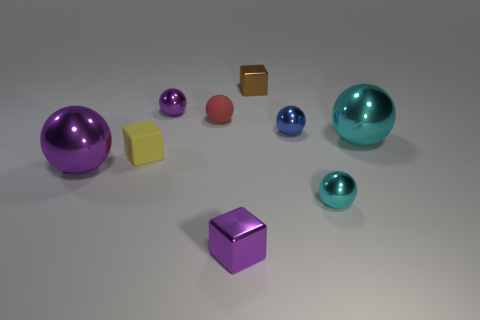What shape is the large thing right of the purple metal ball that is left of the yellow rubber object?
Ensure brevity in your answer.  Sphere. What is the shape of the small red thing on the right side of the large purple ball?
Ensure brevity in your answer.  Sphere. What number of small metallic cubes are the same color as the rubber cube?
Make the answer very short. 0. What color is the small matte cube?
Provide a succinct answer. Yellow. How many tiny cubes are on the right side of the metal block that is in front of the small purple sphere?
Make the answer very short. 1. Does the yellow object have the same size as the cyan metallic object behind the matte block?
Your answer should be very brief. No. Is there another brown cube that has the same size as the brown metal cube?
Offer a very short reply. No. There is a small purple object to the left of the purple cube; what is its material?
Give a very brief answer. Metal. What color is the block that is made of the same material as the tiny red thing?
Provide a short and direct response. Yellow. How many metal things are either cyan balls or yellow blocks?
Make the answer very short. 2. 